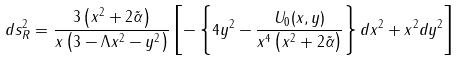<formula> <loc_0><loc_0><loc_500><loc_500>d s _ { R } ^ { 2 } = \frac { 3 \left ( x ^ { 2 } + 2 \tilde { \alpha } \right ) } { x \left ( 3 - \Lambda x ^ { 2 } - y ^ { 2 } \right ) } \left [ - \left \{ 4 y ^ { 2 } - \frac { U _ { 0 } ( x , y ) } { x ^ { 4 } \left ( x ^ { 2 } + 2 \tilde { \alpha } \right ) } \right \} d x ^ { 2 } + x ^ { 2 } d y ^ { 2 } \right ]</formula> 